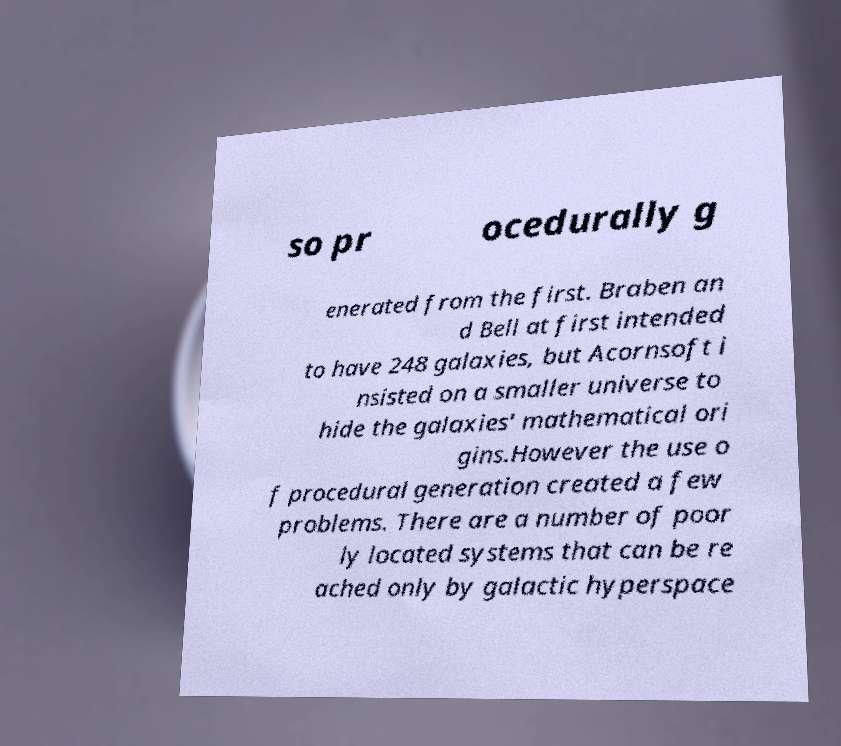Can you read and provide the text displayed in the image?This photo seems to have some interesting text. Can you extract and type it out for me? so pr ocedurally g enerated from the first. Braben an d Bell at first intended to have 248 galaxies, but Acornsoft i nsisted on a smaller universe to hide the galaxies' mathematical ori gins.However the use o f procedural generation created a few problems. There are a number of poor ly located systems that can be re ached only by galactic hyperspace 